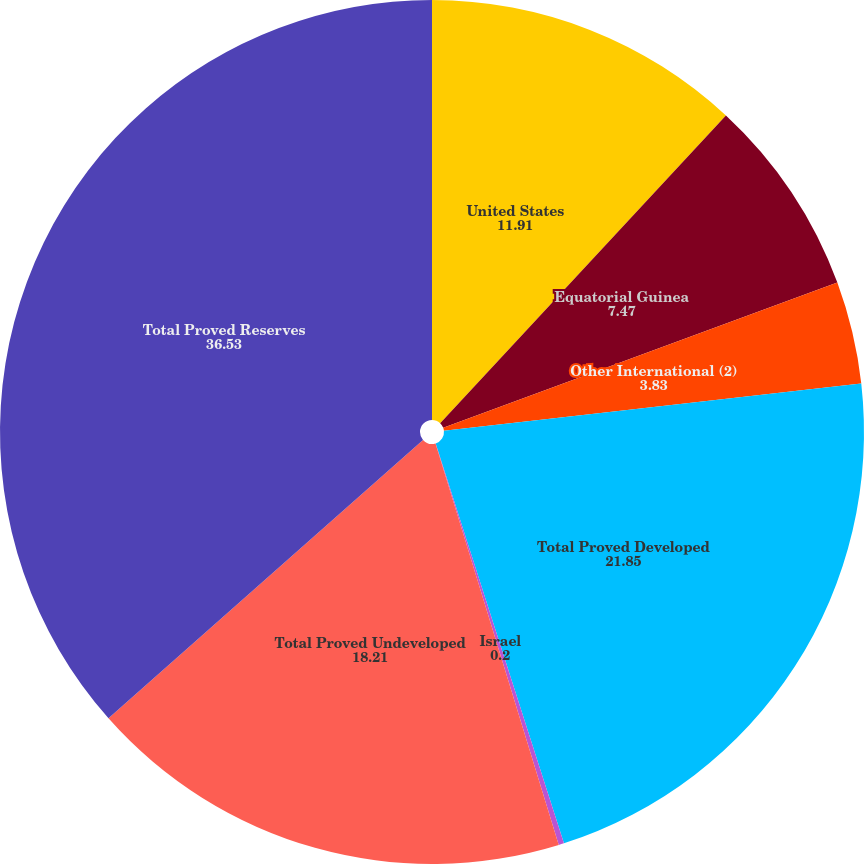Convert chart to OTSL. <chart><loc_0><loc_0><loc_500><loc_500><pie_chart><fcel>United States<fcel>Equatorial Guinea<fcel>Other International (2)<fcel>Total Proved Developed<fcel>Israel<fcel>Total Proved Undeveloped<fcel>Total Proved Reserves<nl><fcel>11.91%<fcel>7.47%<fcel>3.83%<fcel>21.85%<fcel>0.2%<fcel>18.21%<fcel>36.53%<nl></chart> 